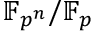Convert formula to latex. <formula><loc_0><loc_0><loc_500><loc_500>\mathbb { F } _ { p ^ { n } } / \mathbb { F } _ { p }</formula> 